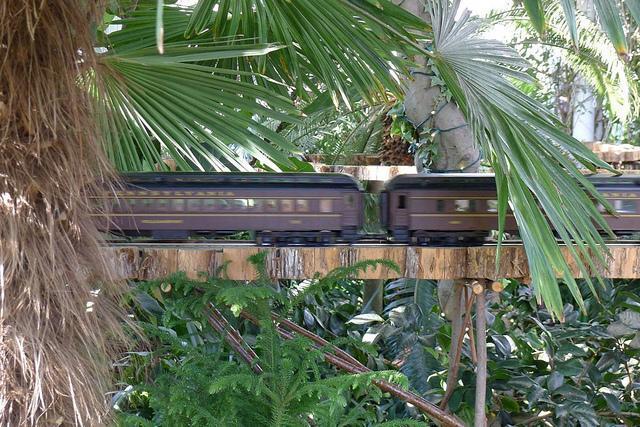How many bottles can be seen?
Give a very brief answer. 0. 